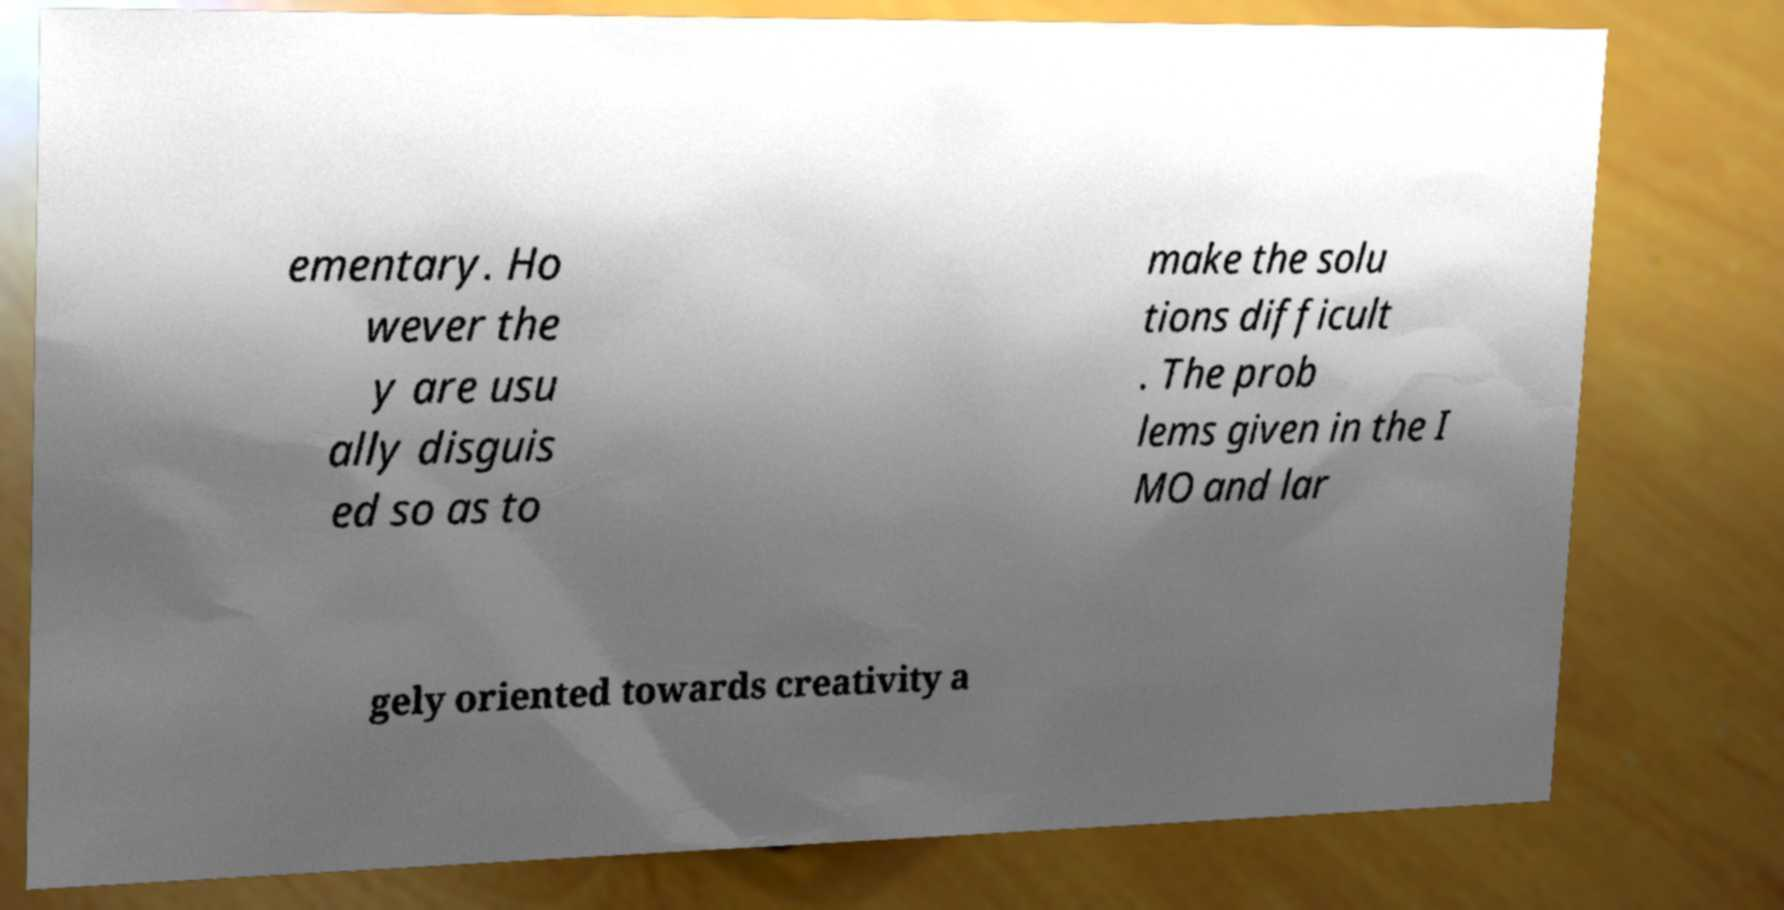Please identify and transcribe the text found in this image. ementary. Ho wever the y are usu ally disguis ed so as to make the solu tions difficult . The prob lems given in the I MO and lar gely oriented towards creativity a 